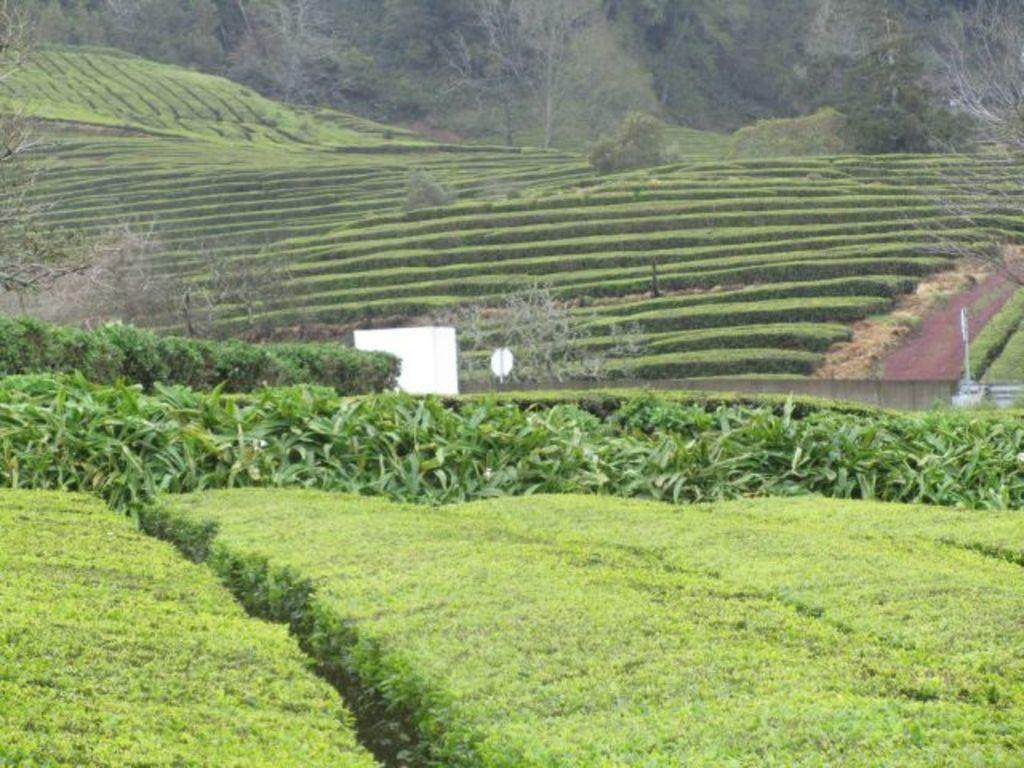What type of vegetation can be seen in the image? There are plants, bushes, and trees in the image. Can you describe any other objects present in the image? There are other objects in the image, but their specific details are not mentioned in the provided facts. How many geese are seen bursting at the end of the image? There are no geese or bursting actions present in the image. 